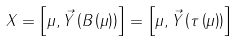<formula> <loc_0><loc_0><loc_500><loc_500>X = \left [ \mu , \vec { Y } \left ( B \left ( \mu \right ) \right ) \right ] = \left [ \mu , \vec { Y } \left ( \tau \left ( \mu \right ) \right ) \right ]</formula> 